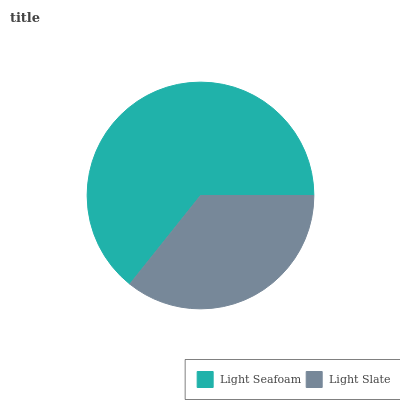Is Light Slate the minimum?
Answer yes or no. Yes. Is Light Seafoam the maximum?
Answer yes or no. Yes. Is Light Slate the maximum?
Answer yes or no. No. Is Light Seafoam greater than Light Slate?
Answer yes or no. Yes. Is Light Slate less than Light Seafoam?
Answer yes or no. Yes. Is Light Slate greater than Light Seafoam?
Answer yes or no. No. Is Light Seafoam less than Light Slate?
Answer yes or no. No. Is Light Seafoam the high median?
Answer yes or no. Yes. Is Light Slate the low median?
Answer yes or no. Yes. Is Light Slate the high median?
Answer yes or no. No. Is Light Seafoam the low median?
Answer yes or no. No. 